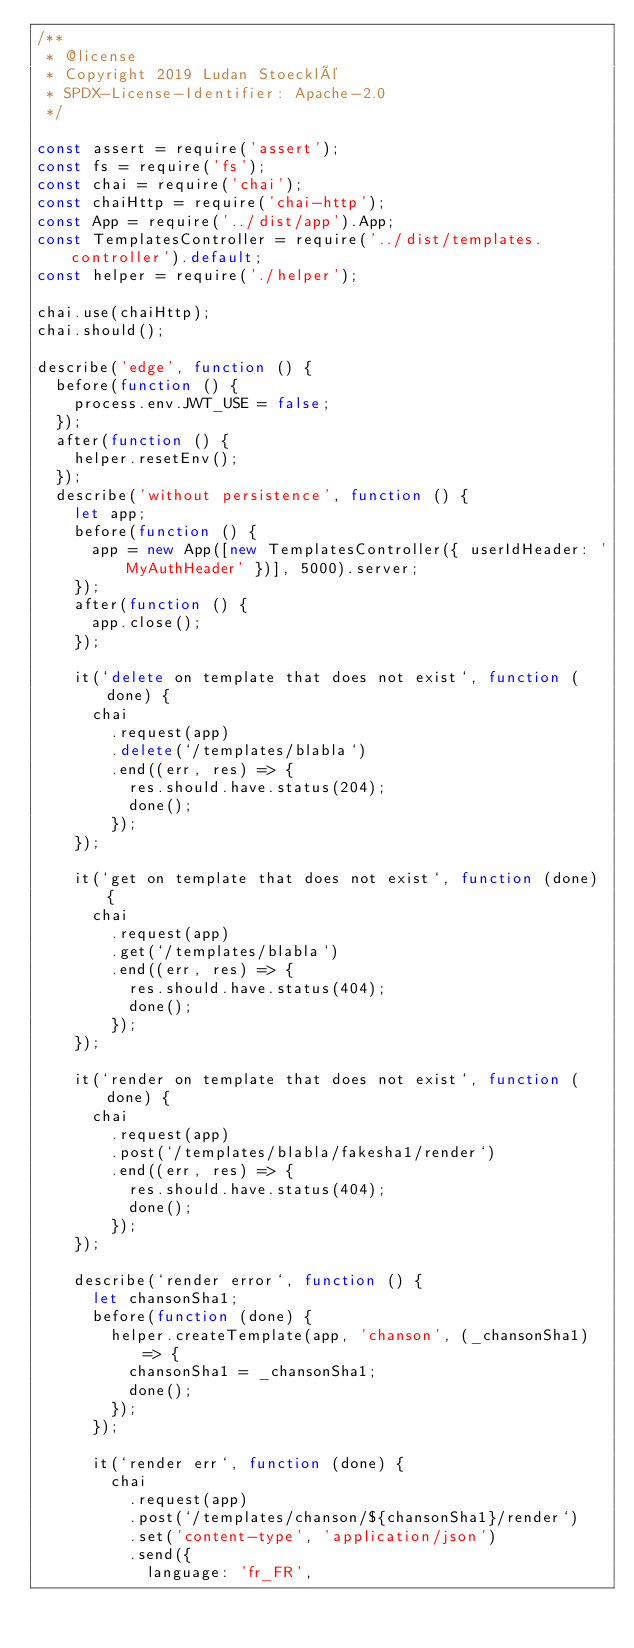Convert code to text. <code><loc_0><loc_0><loc_500><loc_500><_JavaScript_>/**
 * @license
 * Copyright 2019 Ludan Stoecklé
 * SPDX-License-Identifier: Apache-2.0
 */

const assert = require('assert');
const fs = require('fs');
const chai = require('chai');
const chaiHttp = require('chai-http');
const App = require('../dist/app').App;
const TemplatesController = require('../dist/templates.controller').default;
const helper = require('./helper');

chai.use(chaiHttp);
chai.should();

describe('edge', function () {
  before(function () {
    process.env.JWT_USE = false;
  });
  after(function () {
    helper.resetEnv();
  });
  describe('without persistence', function () {
    let app;
    before(function () {
      app = new App([new TemplatesController({ userIdHeader: 'MyAuthHeader' })], 5000).server;
    });
    after(function () {
      app.close();
    });

    it(`delete on template that does not exist`, function (done) {
      chai
        .request(app)
        .delete(`/templates/blabla`)
        .end((err, res) => {
          res.should.have.status(204);
          done();
        });
    });

    it(`get on template that does not exist`, function (done) {
      chai
        .request(app)
        .get(`/templates/blabla`)
        .end((err, res) => {
          res.should.have.status(404);
          done();
        });
    });

    it(`render on template that does not exist`, function (done) {
      chai
        .request(app)
        .post(`/templates/blabla/fakesha1/render`)
        .end((err, res) => {
          res.should.have.status(404);
          done();
        });
    });

    describe(`render error`, function () {
      let chansonSha1;
      before(function (done) {
        helper.createTemplate(app, 'chanson', (_chansonSha1) => {
          chansonSha1 = _chansonSha1;
          done();
        });
      });

      it(`render err`, function (done) {
        chai
          .request(app)
          .post(`/templates/chanson/${chansonSha1}/render`)
          .set('content-type', 'application/json')
          .send({
            language: 'fr_FR',</code> 